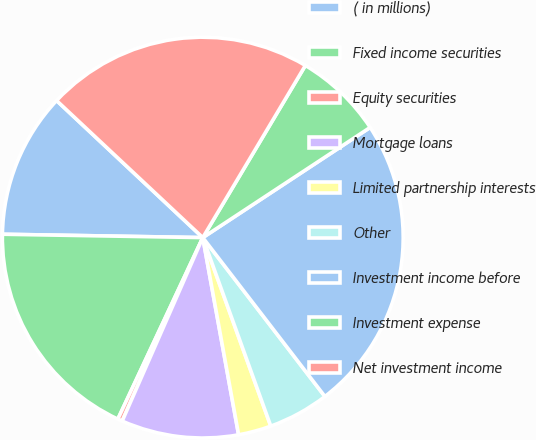Convert chart to OTSL. <chart><loc_0><loc_0><loc_500><loc_500><pie_chart><fcel>( in millions)<fcel>Fixed income securities<fcel>Equity securities<fcel>Mortgage loans<fcel>Limited partnership interests<fcel>Other<fcel>Investment income before<fcel>Investment expense<fcel>Net investment income<nl><fcel>11.72%<fcel>18.3%<fcel>0.38%<fcel>9.45%<fcel>2.65%<fcel>4.92%<fcel>23.84%<fcel>7.18%<fcel>21.57%<nl></chart> 